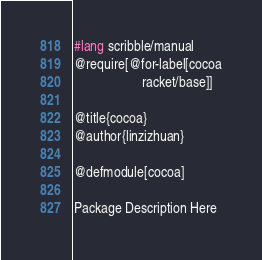Convert code to text. <code><loc_0><loc_0><loc_500><loc_500><_Racket_>#lang scribble/manual
@require[@for-label[cocoa
                    racket/base]]

@title{cocoa}
@author{linzizhuan}

@defmodule[cocoa]

Package Description Here
</code> 